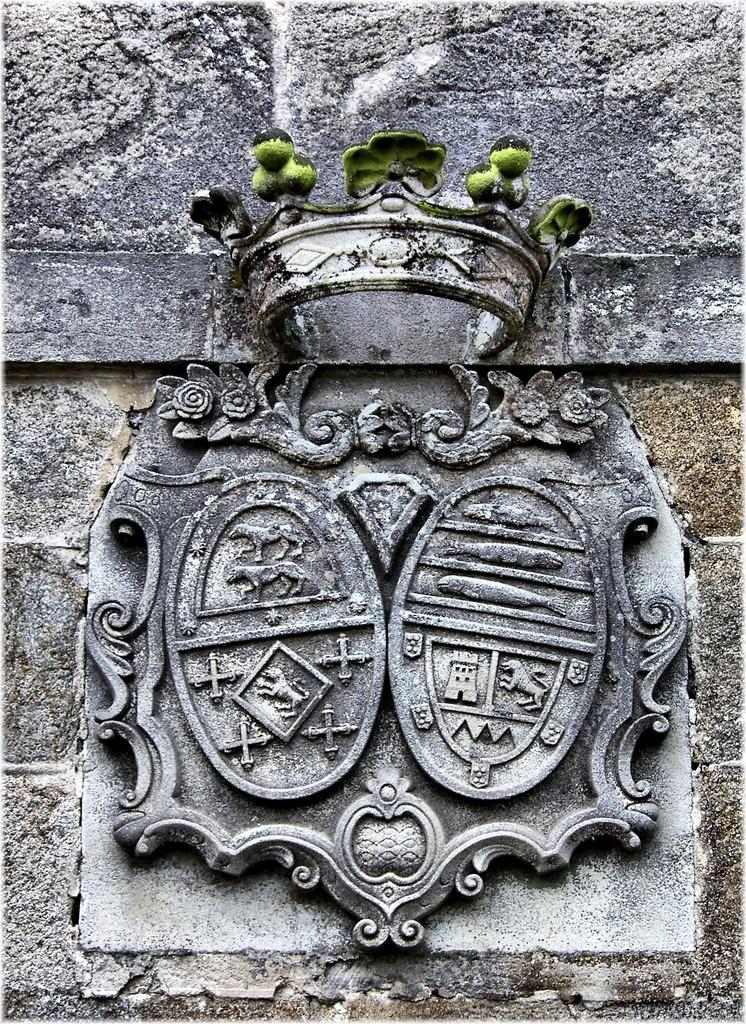What is depicted on the wall in the image? There is an architecture on the wall in the image. How many spiders are crawling on the architecture in the image? There are no spiders present in the image; it features an architecture on the wall. What type of underwear is hanging on the architecture in the image? There is no underwear present in the image; it features an architecture on the wall. 